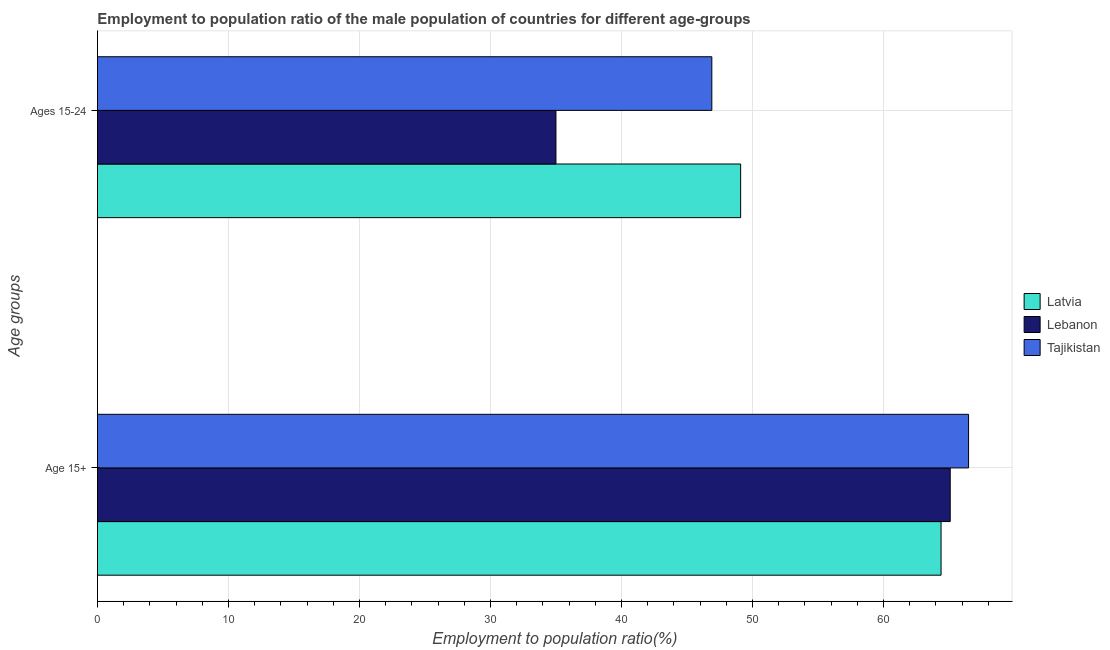How many groups of bars are there?
Ensure brevity in your answer.  2. Are the number of bars on each tick of the Y-axis equal?
Give a very brief answer. Yes. What is the label of the 1st group of bars from the top?
Your response must be concise. Ages 15-24. What is the employment to population ratio(age 15-24) in Tajikistan?
Keep it short and to the point. 46.9. Across all countries, what is the maximum employment to population ratio(age 15-24)?
Make the answer very short. 49.1. Across all countries, what is the minimum employment to population ratio(age 15+)?
Your answer should be very brief. 64.4. In which country was the employment to population ratio(age 15-24) maximum?
Give a very brief answer. Latvia. In which country was the employment to population ratio(age 15-24) minimum?
Your response must be concise. Lebanon. What is the total employment to population ratio(age 15+) in the graph?
Give a very brief answer. 196. What is the difference between the employment to population ratio(age 15+) in Latvia and that in Tajikistan?
Offer a very short reply. -2.1. What is the difference between the employment to population ratio(age 15-24) in Latvia and the employment to population ratio(age 15+) in Lebanon?
Ensure brevity in your answer.  -16. What is the average employment to population ratio(age 15-24) per country?
Your answer should be very brief. 43.67. What is the difference between the employment to population ratio(age 15+) and employment to population ratio(age 15-24) in Lebanon?
Your answer should be compact. 30.1. What is the ratio of the employment to population ratio(age 15-24) in Lebanon to that in Tajikistan?
Your response must be concise. 0.75. Is the employment to population ratio(age 15+) in Lebanon less than that in Latvia?
Your response must be concise. No. What does the 2nd bar from the top in Age 15+ represents?
Your answer should be compact. Lebanon. What does the 1st bar from the bottom in Age 15+ represents?
Your response must be concise. Latvia. Are all the bars in the graph horizontal?
Your answer should be compact. Yes. What is the difference between two consecutive major ticks on the X-axis?
Your response must be concise. 10. Are the values on the major ticks of X-axis written in scientific E-notation?
Provide a short and direct response. No. Does the graph contain grids?
Make the answer very short. Yes. Where does the legend appear in the graph?
Give a very brief answer. Center right. How many legend labels are there?
Provide a succinct answer. 3. What is the title of the graph?
Make the answer very short. Employment to population ratio of the male population of countries for different age-groups. What is the label or title of the Y-axis?
Ensure brevity in your answer.  Age groups. What is the Employment to population ratio(%) of Latvia in Age 15+?
Keep it short and to the point. 64.4. What is the Employment to population ratio(%) of Lebanon in Age 15+?
Make the answer very short. 65.1. What is the Employment to population ratio(%) in Tajikistan in Age 15+?
Your response must be concise. 66.5. What is the Employment to population ratio(%) in Latvia in Ages 15-24?
Make the answer very short. 49.1. What is the Employment to population ratio(%) of Tajikistan in Ages 15-24?
Your response must be concise. 46.9. Across all Age groups, what is the maximum Employment to population ratio(%) of Latvia?
Your response must be concise. 64.4. Across all Age groups, what is the maximum Employment to population ratio(%) in Lebanon?
Make the answer very short. 65.1. Across all Age groups, what is the maximum Employment to population ratio(%) of Tajikistan?
Provide a short and direct response. 66.5. Across all Age groups, what is the minimum Employment to population ratio(%) in Latvia?
Your response must be concise. 49.1. Across all Age groups, what is the minimum Employment to population ratio(%) of Lebanon?
Ensure brevity in your answer.  35. Across all Age groups, what is the minimum Employment to population ratio(%) in Tajikistan?
Give a very brief answer. 46.9. What is the total Employment to population ratio(%) in Latvia in the graph?
Provide a short and direct response. 113.5. What is the total Employment to population ratio(%) in Lebanon in the graph?
Offer a terse response. 100.1. What is the total Employment to population ratio(%) in Tajikistan in the graph?
Give a very brief answer. 113.4. What is the difference between the Employment to population ratio(%) of Latvia in Age 15+ and that in Ages 15-24?
Offer a terse response. 15.3. What is the difference between the Employment to population ratio(%) of Lebanon in Age 15+ and that in Ages 15-24?
Your answer should be compact. 30.1. What is the difference between the Employment to population ratio(%) in Tajikistan in Age 15+ and that in Ages 15-24?
Give a very brief answer. 19.6. What is the difference between the Employment to population ratio(%) in Latvia in Age 15+ and the Employment to population ratio(%) in Lebanon in Ages 15-24?
Your answer should be very brief. 29.4. What is the average Employment to population ratio(%) of Latvia per Age groups?
Your answer should be compact. 56.75. What is the average Employment to population ratio(%) of Lebanon per Age groups?
Your response must be concise. 50.05. What is the average Employment to population ratio(%) of Tajikistan per Age groups?
Offer a terse response. 56.7. What is the difference between the Employment to population ratio(%) in Latvia and Employment to population ratio(%) in Tajikistan in Age 15+?
Make the answer very short. -2.1. What is the difference between the Employment to population ratio(%) of Latvia and Employment to population ratio(%) of Lebanon in Ages 15-24?
Offer a terse response. 14.1. What is the difference between the Employment to population ratio(%) of Latvia and Employment to population ratio(%) of Tajikistan in Ages 15-24?
Your answer should be compact. 2.2. What is the difference between the Employment to population ratio(%) of Lebanon and Employment to population ratio(%) of Tajikistan in Ages 15-24?
Provide a short and direct response. -11.9. What is the ratio of the Employment to population ratio(%) of Latvia in Age 15+ to that in Ages 15-24?
Provide a succinct answer. 1.31. What is the ratio of the Employment to population ratio(%) of Lebanon in Age 15+ to that in Ages 15-24?
Keep it short and to the point. 1.86. What is the ratio of the Employment to population ratio(%) in Tajikistan in Age 15+ to that in Ages 15-24?
Offer a very short reply. 1.42. What is the difference between the highest and the second highest Employment to population ratio(%) of Lebanon?
Provide a succinct answer. 30.1. What is the difference between the highest and the second highest Employment to population ratio(%) in Tajikistan?
Ensure brevity in your answer.  19.6. What is the difference between the highest and the lowest Employment to population ratio(%) of Lebanon?
Provide a succinct answer. 30.1. What is the difference between the highest and the lowest Employment to population ratio(%) in Tajikistan?
Offer a terse response. 19.6. 